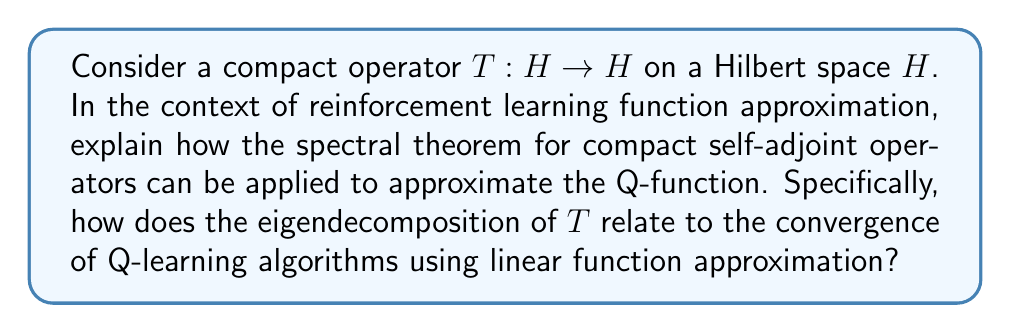Can you answer this question? To understand this problem, let's break it down into steps:

1) Compact operators in Hilbert spaces:
   A compact operator $T: H \rightarrow H$ on a Hilbert space $H$ is one that maps bounded sets to relatively compact sets. In simpler terms, it "compresses" the space.

2) Spectral theorem for compact self-adjoint operators:
   For a compact self-adjoint operator $T$, the spectral theorem states that:
   
   $$T = \sum_{i=1}^{\infty} \lambda_i \langle \cdot, e_i \rangle e_i$$
   
   where $\{\lambda_i\}$ are the eigenvalues of $T$ and $\{e_i\}$ are the corresponding orthonormal eigenvectors.

3) Q-function in reinforcement learning:
   The Q-function $Q(s,a)$ represents the expected cumulative reward starting from state $s$, taking action $a$, and then following the optimal policy.

4) Linear function approximation in RL:
   In linear function approximation, we represent the Q-function as:
   
   $$Q(s,a) \approx \sum_{i=1}^{n} w_i \phi_i(s,a)$$
   
   where $\{\phi_i\}$ are basis functions and $\{w_i\}$ are weights to be learned.

5) Connection to compact operators:
   We can view the Q-function as an element of a Hilbert space of functions. The approximation process can be seen as applying a compact operator $T$ to this function.

6) Eigendecomposition and convergence:
   The eigendecomposition of $T$ gives us a natural set of basis functions $\{e_i\}$ to use for function approximation. The eigenvalues $\{\lambda_i\}$ tell us how important each basis function is.

7) Convergence of Q-learning:
   In Q-learning with linear function approximation, the convergence rate is related to the spectral properties of the operator. Specifically, the convergence rate depends on the ratio of the largest to the smallest non-zero eigenvalue of the covariance matrix of the features, which is related to the spectrum of our compact operator $T$.

8) Practical implications:
   By choosing basis functions that correspond to the most significant eigenvectors of $T$, we can achieve faster convergence and better approximation of the Q-function with fewer parameters.
Answer: The spectral theorem for compact self-adjoint operators provides an optimal basis for function approximation in reinforcement learning. By using the eigenvectors of the compact operator as basis functions, ordered by the magnitude of their corresponding eigenvalues, we can achieve efficient approximation of the Q-function. This approach leads to faster convergence of Q-learning algorithms with linear function approximation, as the convergence rate is related to the spectral properties (eigenvalues) of the operator. 